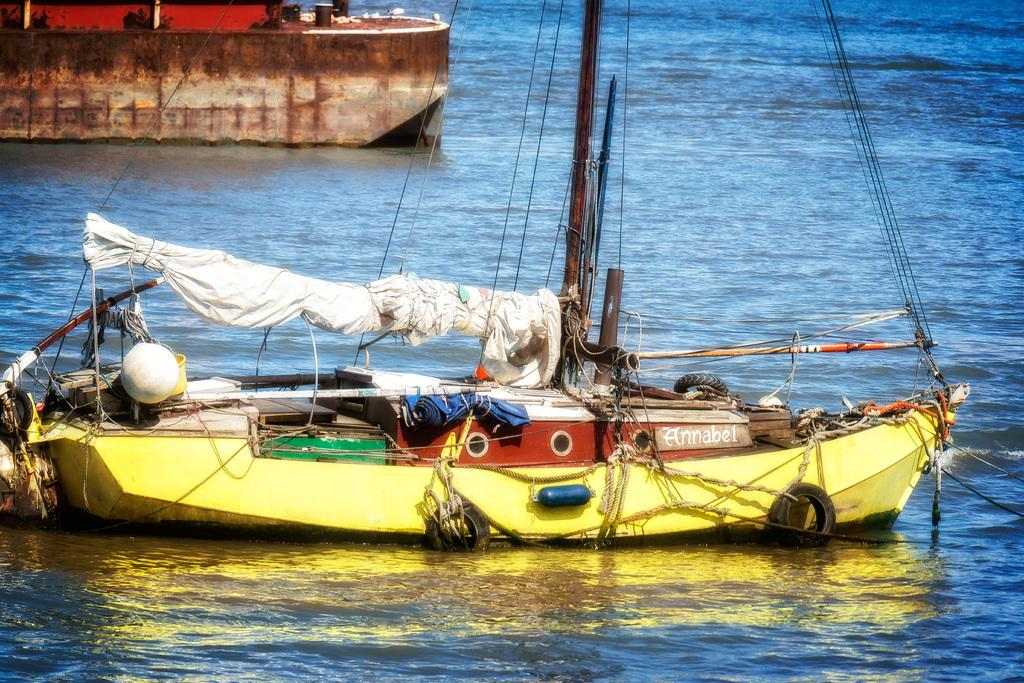What type of vehicles are present in the image? There are ships in the image. Can you describe the appearance of the ships? The ships are in different colors. What other objects can be seen in the image? There are wires and poles in the image. What is inside the ships? There are objects inside the ships. What is the color of the water in the image? The water is visible in the image and has a blue color. Can you tell me how many crates are stacked on the rat in the image? There is no rat or crate present in the image. What type of ship is shown in the image? The image contains multiple ships, but it does not specify the type of each ship. 